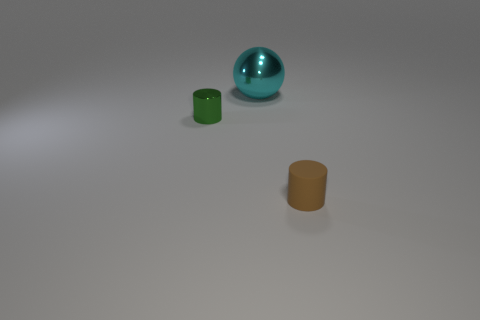Can you tell the size of these objects? It's difficult to provide accurate sizes without a reference, but based on the image, the objects appear to be small, possibly a few centimeters in diameter for the sphere and a similar height for the cylindrical objects.  Could these objects have a specific use or function together? The items do not seem to have an apparent direct relation or specific combined function, but it's possible that they could be part of a larger set, such as game pieces or components for a model or assembly. 